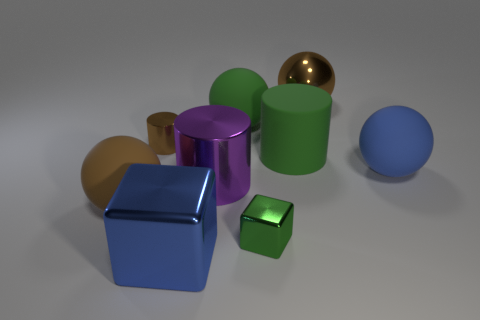Subtract all blue matte balls. How many balls are left? 3 Add 1 blocks. How many objects exist? 10 Subtract 1 spheres. How many spheres are left? 3 Subtract all blue cubes. How many cubes are left? 1 Subtract 0 brown blocks. How many objects are left? 9 Subtract all spheres. How many objects are left? 5 Subtract all cyan cubes. Subtract all purple spheres. How many cubes are left? 2 Subtract all green cylinders. How many brown balls are left? 2 Subtract all large metallic cylinders. Subtract all rubber objects. How many objects are left? 4 Add 3 big brown metallic things. How many big brown metallic things are left? 4 